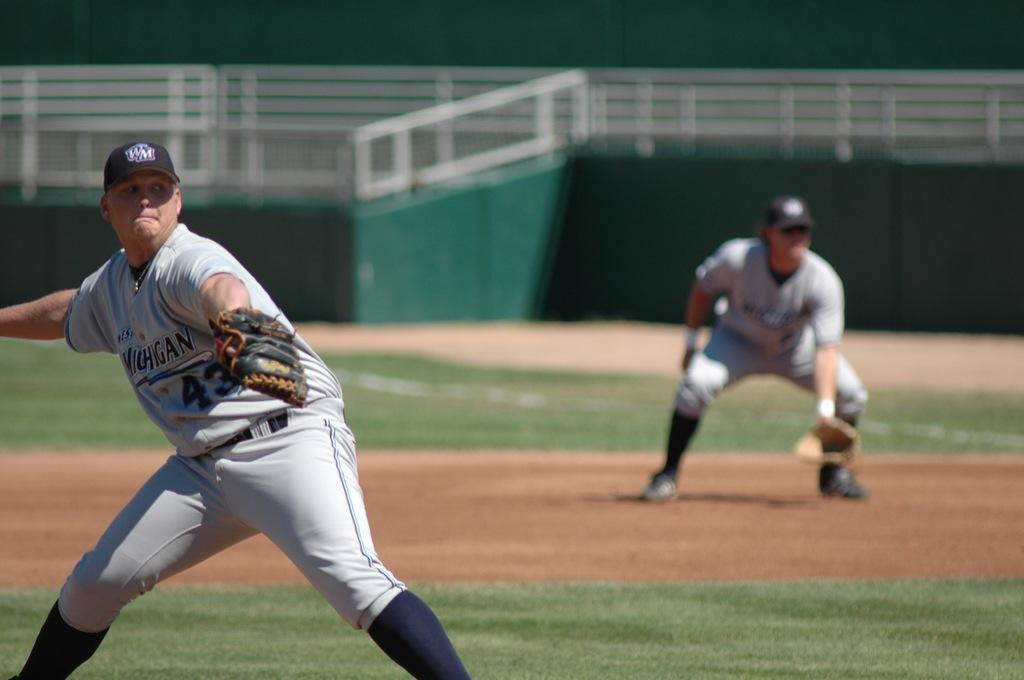How would you summarize this image in a sentence or two? In this image we can see two players on the ground and behind them, we can see a fence. 